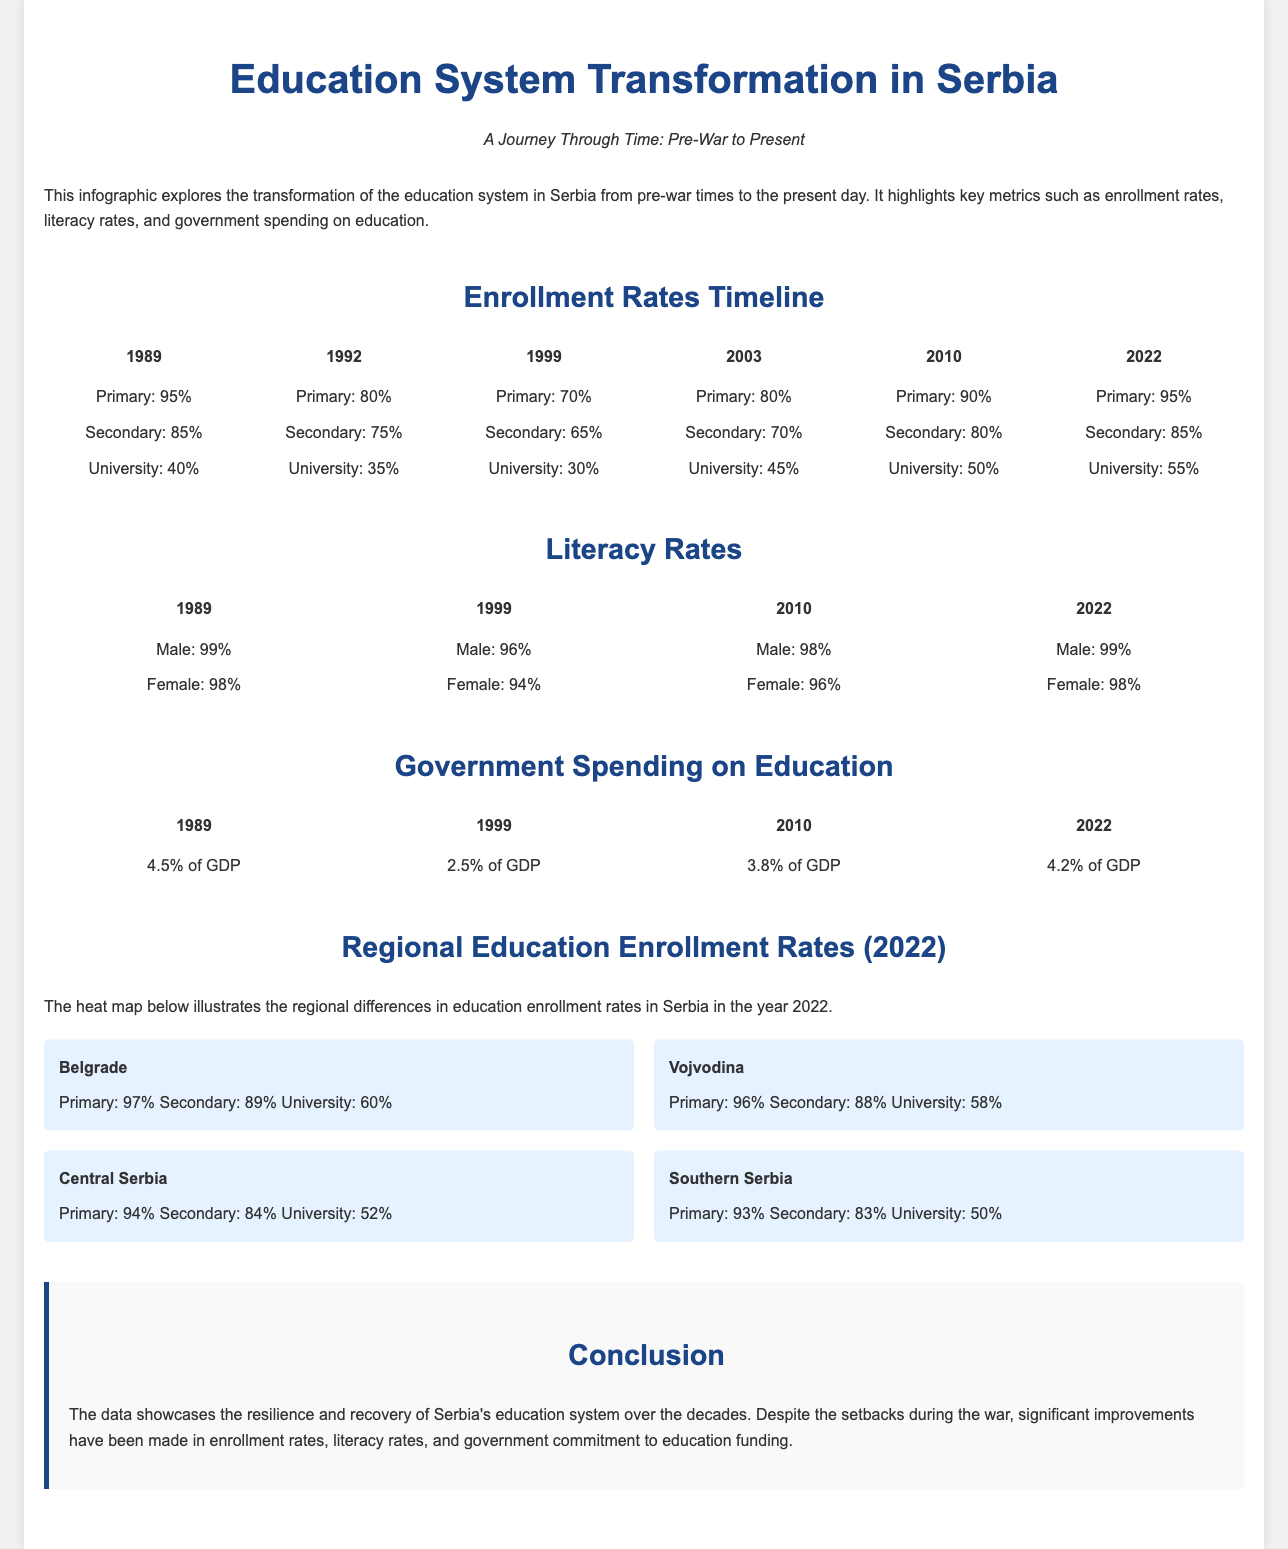What were the primary enrollment rates in 1989? The primary enrollment rate in 1989 was 95%.
Answer: 95% What is the literacy rate for females in 2022? The literacy rate for females in 2022 is 98%.
Answer: 98% What percentage of GDP was spent on education in 1999? The percentage of GDP spent on education in 1999 was 2.5%.
Answer: 2.5% Which region had the highest university enrollment rate in 2022? The region with the highest university enrollment rate in 2022 was Belgrade with 60%.
Answer: Belgrade What trend can be observed in the primary enrollment rates from 1992 to 2010? The trend observed is an increase in primary enrollment rates from 80% in 1992 to 90% in 2010.
Answer: Increase What was the percentage of secondary enrollment in Central Serbia in 2022? The percentage of secondary enrollment in Central Serbia in 2022 was 84%.
Answer: 84% How did men's literacy change from 1999 to 2010? Men’s literacy increased from 96% in 1999 to 98% in 2010.
Answer: Increased What does the heat map illustrate? The heat map illustrates regional differences in education enrollment rates in Serbia for 2022.
Answer: Regional differences in enrollment rates What is a conclusion drawn about Serbia's education system over the decades? The conclusion drawn is that significant improvements have been made in enrollment rates and literacy despite setbacks.
Answer: Significant improvements 